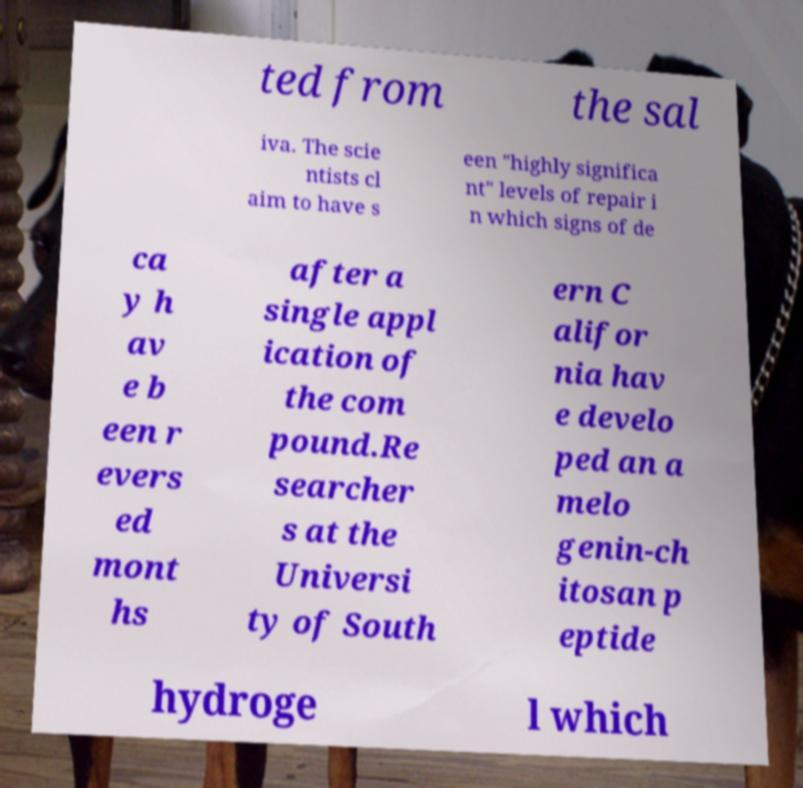Can you read and provide the text displayed in the image?This photo seems to have some interesting text. Can you extract and type it out for me? ted from the sal iva. The scie ntists cl aim to have s een "highly significa nt" levels of repair i n which signs of de ca y h av e b een r evers ed mont hs after a single appl ication of the com pound.Re searcher s at the Universi ty of South ern C alifor nia hav e develo ped an a melo genin-ch itosan p eptide hydroge l which 